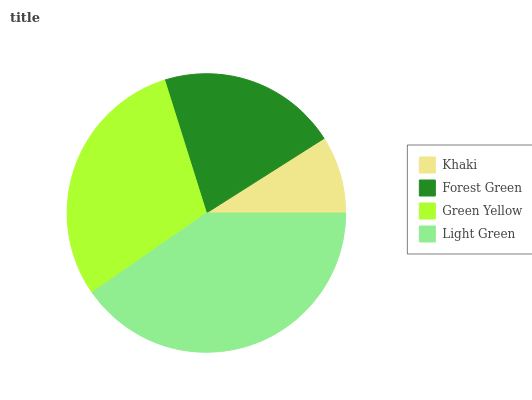Is Khaki the minimum?
Answer yes or no. Yes. Is Light Green the maximum?
Answer yes or no. Yes. Is Forest Green the minimum?
Answer yes or no. No. Is Forest Green the maximum?
Answer yes or no. No. Is Forest Green greater than Khaki?
Answer yes or no. Yes. Is Khaki less than Forest Green?
Answer yes or no. Yes. Is Khaki greater than Forest Green?
Answer yes or no. No. Is Forest Green less than Khaki?
Answer yes or no. No. Is Green Yellow the high median?
Answer yes or no. Yes. Is Forest Green the low median?
Answer yes or no. Yes. Is Khaki the high median?
Answer yes or no. No. Is Green Yellow the low median?
Answer yes or no. No. 